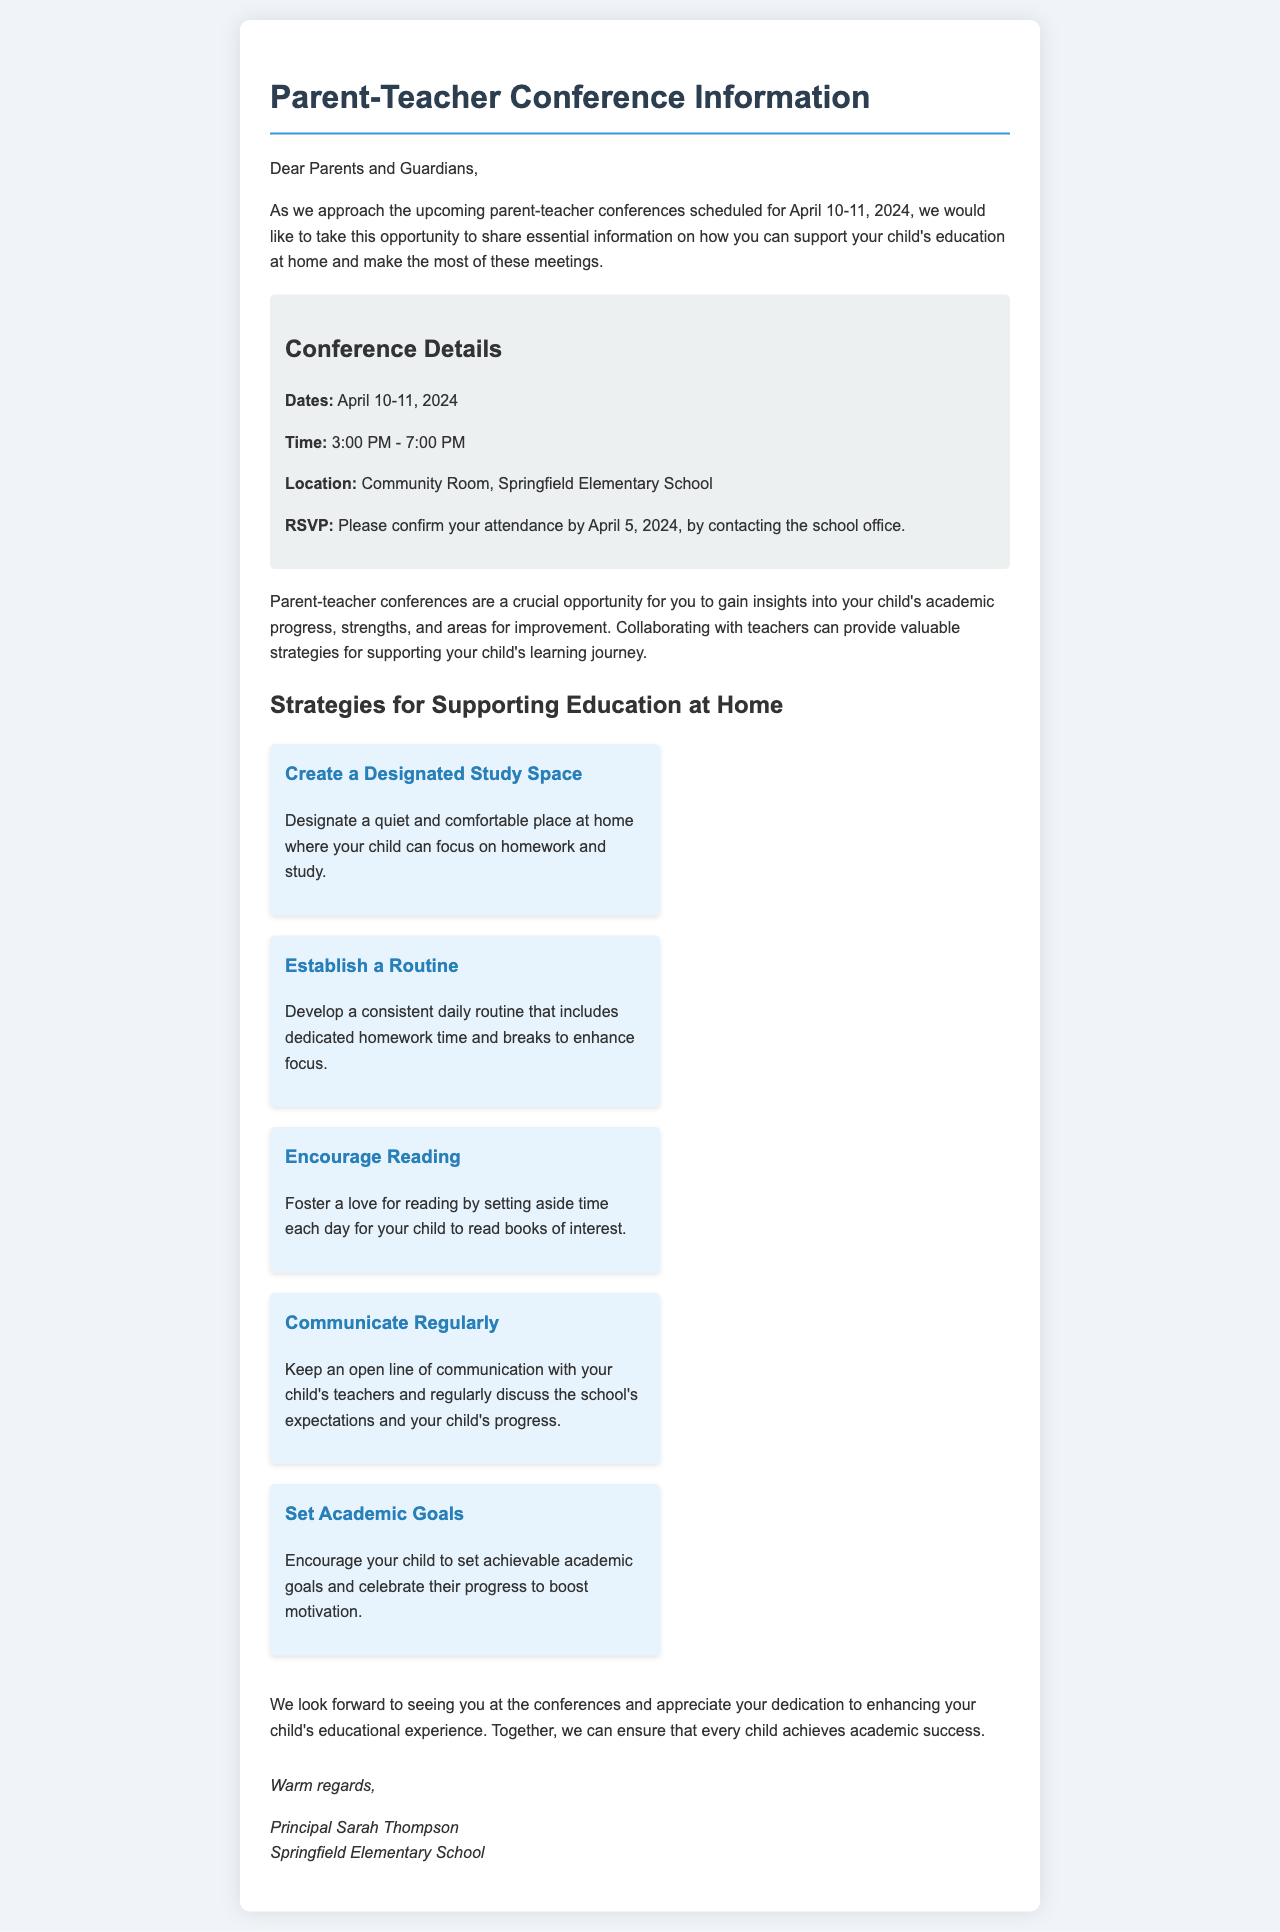What are the conference dates? The conference dates are explicitly mentioned in the document, which states they are scheduled for April 10-11, 2024.
Answer: April 10-11, 2024 What time do the conferences start? The document provides the time for the conferences, stating they start at 3:00 PM.
Answer: 3:00 PM Where will the conferences be held? The location of the conferences is clearly identified in the document as the Community Room at Springfield Elementary School.
Answer: Community Room, Springfield Elementary School What is one strategy mentioned for supporting education at home? The letter lists several strategies, and one example of a strategy is to create a designated study space.
Answer: Create a Designated Study Space When is the RSVP deadline? The document specifies the deadline for RSVPs as April 5, 2024.
Answer: April 5, 2024 What is the primary purpose of the parent-teacher conferences? The document indicates that the conferences are an opportunity to gain insights into the child's academic progress, strengths, and areas for improvement.
Answer: Gain insights into academic progress Who is the author of the letter? The signature at the bottom of the letter identifies the author as Principal Sarah Thompson.
Answer: Principal Sarah Thompson What should parents do if they plan to attend? Parents are instructed to confirm their attendance by contacting the school office.
Answer: Confirm attendance by contacting the school office How can parents encourage their child's academic motivation? The document suggests that parents can encourage motivation by setting achievable academic goals.
Answer: Set achievable academic goals 